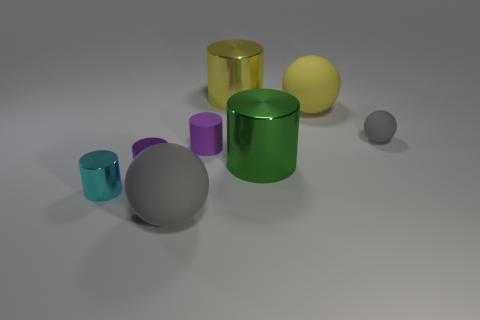Are any small brown matte objects visible?
Your response must be concise. No. There is a large object that is both in front of the small purple matte cylinder and behind the large gray thing; what is its shape?
Give a very brief answer. Cylinder. How big is the sphere that is in front of the tiny gray object?
Your answer should be very brief. Large. Does the big rubber ball behind the small cyan metallic thing have the same color as the small rubber cylinder?
Ensure brevity in your answer.  No. What number of other yellow shiny things are the same shape as the big yellow metallic thing?
Keep it short and to the point. 0. What number of objects are shiny objects that are in front of the yellow metallic cylinder or small rubber objects that are on the right side of the small purple matte object?
Offer a terse response. 4. How many purple things are small cylinders or tiny rubber objects?
Offer a very short reply. 2. The large thing that is behind the green metal object and to the left of the large green metal cylinder is made of what material?
Ensure brevity in your answer.  Metal. Is the material of the tiny cyan thing the same as the big gray thing?
Offer a very short reply. No. What number of other yellow cylinders are the same size as the yellow cylinder?
Provide a succinct answer. 0. 